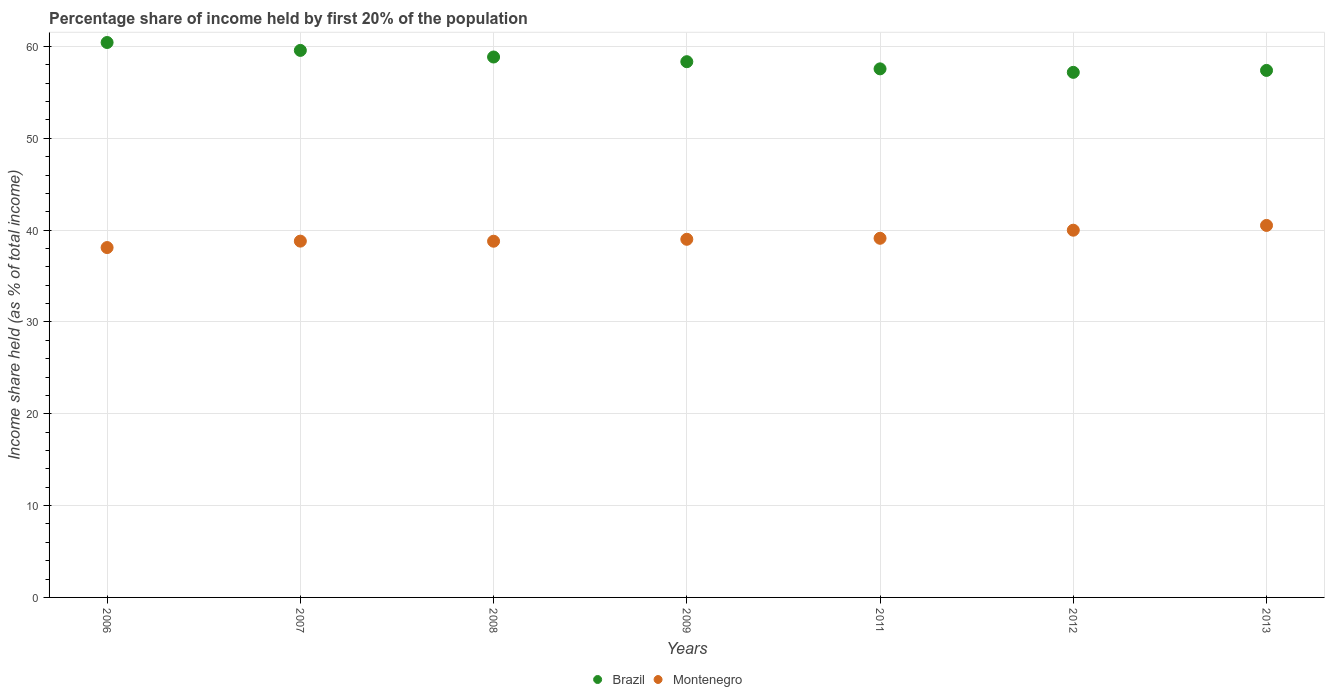How many different coloured dotlines are there?
Make the answer very short. 2. What is the share of income held by first 20% of the population in Montenegro in 2013?
Keep it short and to the point. 40.51. Across all years, what is the maximum share of income held by first 20% of the population in Brazil?
Keep it short and to the point. 60.43. Across all years, what is the minimum share of income held by first 20% of the population in Brazil?
Ensure brevity in your answer.  57.18. In which year was the share of income held by first 20% of the population in Montenegro minimum?
Your response must be concise. 2006. What is the total share of income held by first 20% of the population in Montenegro in the graph?
Offer a very short reply. 274.3. What is the difference between the share of income held by first 20% of the population in Montenegro in 2009 and that in 2011?
Give a very brief answer. -0.11. What is the difference between the share of income held by first 20% of the population in Montenegro in 2006 and the share of income held by first 20% of the population in Brazil in 2009?
Make the answer very short. -20.24. What is the average share of income held by first 20% of the population in Brazil per year?
Offer a terse response. 58.47. In the year 2007, what is the difference between the share of income held by first 20% of the population in Montenegro and share of income held by first 20% of the population in Brazil?
Offer a terse response. -20.77. What is the ratio of the share of income held by first 20% of the population in Montenegro in 2006 to that in 2008?
Your response must be concise. 0.98. Is the share of income held by first 20% of the population in Montenegro in 2009 less than that in 2011?
Your answer should be very brief. Yes. Is the difference between the share of income held by first 20% of the population in Montenegro in 2007 and 2012 greater than the difference between the share of income held by first 20% of the population in Brazil in 2007 and 2012?
Ensure brevity in your answer.  No. What is the difference between the highest and the second highest share of income held by first 20% of the population in Brazil?
Offer a terse response. 0.86. What is the difference between the highest and the lowest share of income held by first 20% of the population in Montenegro?
Ensure brevity in your answer.  2.41. In how many years, is the share of income held by first 20% of the population in Montenegro greater than the average share of income held by first 20% of the population in Montenegro taken over all years?
Ensure brevity in your answer.  2. Is the share of income held by first 20% of the population in Brazil strictly less than the share of income held by first 20% of the population in Montenegro over the years?
Make the answer very short. No. How many years are there in the graph?
Give a very brief answer. 7. What is the difference between two consecutive major ticks on the Y-axis?
Offer a terse response. 10. Are the values on the major ticks of Y-axis written in scientific E-notation?
Make the answer very short. No. Does the graph contain any zero values?
Give a very brief answer. No. Does the graph contain grids?
Make the answer very short. Yes. Where does the legend appear in the graph?
Your answer should be very brief. Bottom center. How are the legend labels stacked?
Offer a terse response. Horizontal. What is the title of the graph?
Your answer should be compact. Percentage share of income held by first 20% of the population. Does "Mali" appear as one of the legend labels in the graph?
Provide a succinct answer. No. What is the label or title of the Y-axis?
Keep it short and to the point. Income share held (as % of total income). What is the Income share held (as % of total income) of Brazil in 2006?
Provide a short and direct response. 60.43. What is the Income share held (as % of total income) of Montenegro in 2006?
Provide a succinct answer. 38.1. What is the Income share held (as % of total income) in Brazil in 2007?
Give a very brief answer. 59.57. What is the Income share held (as % of total income) in Montenegro in 2007?
Your answer should be compact. 38.8. What is the Income share held (as % of total income) of Brazil in 2008?
Keep it short and to the point. 58.85. What is the Income share held (as % of total income) in Montenegro in 2008?
Give a very brief answer. 38.79. What is the Income share held (as % of total income) of Brazil in 2009?
Your answer should be compact. 58.34. What is the Income share held (as % of total income) of Montenegro in 2009?
Provide a succinct answer. 39. What is the Income share held (as % of total income) in Brazil in 2011?
Provide a succinct answer. 57.56. What is the Income share held (as % of total income) in Montenegro in 2011?
Your answer should be compact. 39.11. What is the Income share held (as % of total income) in Brazil in 2012?
Make the answer very short. 57.18. What is the Income share held (as % of total income) of Montenegro in 2012?
Give a very brief answer. 39.99. What is the Income share held (as % of total income) in Brazil in 2013?
Your answer should be very brief. 57.39. What is the Income share held (as % of total income) in Montenegro in 2013?
Your answer should be very brief. 40.51. Across all years, what is the maximum Income share held (as % of total income) of Brazil?
Keep it short and to the point. 60.43. Across all years, what is the maximum Income share held (as % of total income) of Montenegro?
Provide a short and direct response. 40.51. Across all years, what is the minimum Income share held (as % of total income) of Brazil?
Offer a very short reply. 57.18. Across all years, what is the minimum Income share held (as % of total income) of Montenegro?
Keep it short and to the point. 38.1. What is the total Income share held (as % of total income) in Brazil in the graph?
Provide a succinct answer. 409.32. What is the total Income share held (as % of total income) in Montenegro in the graph?
Your answer should be compact. 274.3. What is the difference between the Income share held (as % of total income) of Brazil in 2006 and that in 2007?
Ensure brevity in your answer.  0.86. What is the difference between the Income share held (as % of total income) of Montenegro in 2006 and that in 2007?
Your response must be concise. -0.7. What is the difference between the Income share held (as % of total income) in Brazil in 2006 and that in 2008?
Your answer should be compact. 1.58. What is the difference between the Income share held (as % of total income) in Montenegro in 2006 and that in 2008?
Make the answer very short. -0.69. What is the difference between the Income share held (as % of total income) in Brazil in 2006 and that in 2009?
Your answer should be compact. 2.09. What is the difference between the Income share held (as % of total income) of Montenegro in 2006 and that in 2009?
Make the answer very short. -0.9. What is the difference between the Income share held (as % of total income) of Brazil in 2006 and that in 2011?
Offer a very short reply. 2.87. What is the difference between the Income share held (as % of total income) in Montenegro in 2006 and that in 2011?
Provide a short and direct response. -1.01. What is the difference between the Income share held (as % of total income) in Montenegro in 2006 and that in 2012?
Keep it short and to the point. -1.89. What is the difference between the Income share held (as % of total income) of Brazil in 2006 and that in 2013?
Ensure brevity in your answer.  3.04. What is the difference between the Income share held (as % of total income) of Montenegro in 2006 and that in 2013?
Provide a succinct answer. -2.41. What is the difference between the Income share held (as % of total income) of Brazil in 2007 and that in 2008?
Provide a succinct answer. 0.72. What is the difference between the Income share held (as % of total income) of Montenegro in 2007 and that in 2008?
Your answer should be very brief. 0.01. What is the difference between the Income share held (as % of total income) of Brazil in 2007 and that in 2009?
Provide a short and direct response. 1.23. What is the difference between the Income share held (as % of total income) in Brazil in 2007 and that in 2011?
Keep it short and to the point. 2.01. What is the difference between the Income share held (as % of total income) in Montenegro in 2007 and that in 2011?
Ensure brevity in your answer.  -0.31. What is the difference between the Income share held (as % of total income) of Brazil in 2007 and that in 2012?
Give a very brief answer. 2.39. What is the difference between the Income share held (as % of total income) in Montenegro in 2007 and that in 2012?
Your answer should be compact. -1.19. What is the difference between the Income share held (as % of total income) in Brazil in 2007 and that in 2013?
Your answer should be compact. 2.18. What is the difference between the Income share held (as % of total income) in Montenegro in 2007 and that in 2013?
Your answer should be compact. -1.71. What is the difference between the Income share held (as % of total income) of Brazil in 2008 and that in 2009?
Provide a short and direct response. 0.51. What is the difference between the Income share held (as % of total income) in Montenegro in 2008 and that in 2009?
Ensure brevity in your answer.  -0.21. What is the difference between the Income share held (as % of total income) in Brazil in 2008 and that in 2011?
Make the answer very short. 1.29. What is the difference between the Income share held (as % of total income) in Montenegro in 2008 and that in 2011?
Your response must be concise. -0.32. What is the difference between the Income share held (as % of total income) in Brazil in 2008 and that in 2012?
Your answer should be compact. 1.67. What is the difference between the Income share held (as % of total income) of Montenegro in 2008 and that in 2012?
Your answer should be very brief. -1.2. What is the difference between the Income share held (as % of total income) in Brazil in 2008 and that in 2013?
Your response must be concise. 1.46. What is the difference between the Income share held (as % of total income) of Montenegro in 2008 and that in 2013?
Give a very brief answer. -1.72. What is the difference between the Income share held (as % of total income) of Brazil in 2009 and that in 2011?
Ensure brevity in your answer.  0.78. What is the difference between the Income share held (as % of total income) in Montenegro in 2009 and that in 2011?
Give a very brief answer. -0.11. What is the difference between the Income share held (as % of total income) in Brazil in 2009 and that in 2012?
Keep it short and to the point. 1.16. What is the difference between the Income share held (as % of total income) of Montenegro in 2009 and that in 2012?
Your response must be concise. -0.99. What is the difference between the Income share held (as % of total income) of Brazil in 2009 and that in 2013?
Your response must be concise. 0.95. What is the difference between the Income share held (as % of total income) in Montenegro in 2009 and that in 2013?
Keep it short and to the point. -1.51. What is the difference between the Income share held (as % of total income) of Brazil in 2011 and that in 2012?
Your answer should be very brief. 0.38. What is the difference between the Income share held (as % of total income) of Montenegro in 2011 and that in 2012?
Your answer should be very brief. -0.88. What is the difference between the Income share held (as % of total income) of Brazil in 2011 and that in 2013?
Give a very brief answer. 0.17. What is the difference between the Income share held (as % of total income) of Brazil in 2012 and that in 2013?
Ensure brevity in your answer.  -0.21. What is the difference between the Income share held (as % of total income) of Montenegro in 2012 and that in 2013?
Your answer should be very brief. -0.52. What is the difference between the Income share held (as % of total income) in Brazil in 2006 and the Income share held (as % of total income) in Montenegro in 2007?
Your answer should be compact. 21.63. What is the difference between the Income share held (as % of total income) in Brazil in 2006 and the Income share held (as % of total income) in Montenegro in 2008?
Offer a terse response. 21.64. What is the difference between the Income share held (as % of total income) in Brazil in 2006 and the Income share held (as % of total income) in Montenegro in 2009?
Keep it short and to the point. 21.43. What is the difference between the Income share held (as % of total income) of Brazil in 2006 and the Income share held (as % of total income) of Montenegro in 2011?
Offer a very short reply. 21.32. What is the difference between the Income share held (as % of total income) in Brazil in 2006 and the Income share held (as % of total income) in Montenegro in 2012?
Your answer should be very brief. 20.44. What is the difference between the Income share held (as % of total income) in Brazil in 2006 and the Income share held (as % of total income) in Montenegro in 2013?
Offer a terse response. 19.92. What is the difference between the Income share held (as % of total income) in Brazil in 2007 and the Income share held (as % of total income) in Montenegro in 2008?
Your answer should be compact. 20.78. What is the difference between the Income share held (as % of total income) of Brazil in 2007 and the Income share held (as % of total income) of Montenegro in 2009?
Give a very brief answer. 20.57. What is the difference between the Income share held (as % of total income) in Brazil in 2007 and the Income share held (as % of total income) in Montenegro in 2011?
Ensure brevity in your answer.  20.46. What is the difference between the Income share held (as % of total income) of Brazil in 2007 and the Income share held (as % of total income) of Montenegro in 2012?
Your answer should be compact. 19.58. What is the difference between the Income share held (as % of total income) in Brazil in 2007 and the Income share held (as % of total income) in Montenegro in 2013?
Your response must be concise. 19.06. What is the difference between the Income share held (as % of total income) of Brazil in 2008 and the Income share held (as % of total income) of Montenegro in 2009?
Ensure brevity in your answer.  19.85. What is the difference between the Income share held (as % of total income) of Brazil in 2008 and the Income share held (as % of total income) of Montenegro in 2011?
Give a very brief answer. 19.74. What is the difference between the Income share held (as % of total income) of Brazil in 2008 and the Income share held (as % of total income) of Montenegro in 2012?
Offer a terse response. 18.86. What is the difference between the Income share held (as % of total income) in Brazil in 2008 and the Income share held (as % of total income) in Montenegro in 2013?
Offer a terse response. 18.34. What is the difference between the Income share held (as % of total income) in Brazil in 2009 and the Income share held (as % of total income) in Montenegro in 2011?
Give a very brief answer. 19.23. What is the difference between the Income share held (as % of total income) of Brazil in 2009 and the Income share held (as % of total income) of Montenegro in 2012?
Offer a terse response. 18.35. What is the difference between the Income share held (as % of total income) in Brazil in 2009 and the Income share held (as % of total income) in Montenegro in 2013?
Offer a terse response. 17.83. What is the difference between the Income share held (as % of total income) in Brazil in 2011 and the Income share held (as % of total income) in Montenegro in 2012?
Provide a succinct answer. 17.57. What is the difference between the Income share held (as % of total income) in Brazil in 2011 and the Income share held (as % of total income) in Montenegro in 2013?
Give a very brief answer. 17.05. What is the difference between the Income share held (as % of total income) of Brazil in 2012 and the Income share held (as % of total income) of Montenegro in 2013?
Ensure brevity in your answer.  16.67. What is the average Income share held (as % of total income) in Brazil per year?
Your answer should be compact. 58.47. What is the average Income share held (as % of total income) in Montenegro per year?
Give a very brief answer. 39.19. In the year 2006, what is the difference between the Income share held (as % of total income) of Brazil and Income share held (as % of total income) of Montenegro?
Your answer should be compact. 22.33. In the year 2007, what is the difference between the Income share held (as % of total income) in Brazil and Income share held (as % of total income) in Montenegro?
Offer a terse response. 20.77. In the year 2008, what is the difference between the Income share held (as % of total income) in Brazil and Income share held (as % of total income) in Montenegro?
Offer a terse response. 20.06. In the year 2009, what is the difference between the Income share held (as % of total income) in Brazil and Income share held (as % of total income) in Montenegro?
Provide a short and direct response. 19.34. In the year 2011, what is the difference between the Income share held (as % of total income) in Brazil and Income share held (as % of total income) in Montenegro?
Provide a short and direct response. 18.45. In the year 2012, what is the difference between the Income share held (as % of total income) of Brazil and Income share held (as % of total income) of Montenegro?
Provide a succinct answer. 17.19. In the year 2013, what is the difference between the Income share held (as % of total income) in Brazil and Income share held (as % of total income) in Montenegro?
Keep it short and to the point. 16.88. What is the ratio of the Income share held (as % of total income) of Brazil in 2006 to that in 2007?
Your answer should be very brief. 1.01. What is the ratio of the Income share held (as % of total income) of Montenegro in 2006 to that in 2007?
Ensure brevity in your answer.  0.98. What is the ratio of the Income share held (as % of total income) in Brazil in 2006 to that in 2008?
Your answer should be compact. 1.03. What is the ratio of the Income share held (as % of total income) of Montenegro in 2006 to that in 2008?
Provide a succinct answer. 0.98. What is the ratio of the Income share held (as % of total income) of Brazil in 2006 to that in 2009?
Offer a very short reply. 1.04. What is the ratio of the Income share held (as % of total income) of Montenegro in 2006 to that in 2009?
Provide a succinct answer. 0.98. What is the ratio of the Income share held (as % of total income) in Brazil in 2006 to that in 2011?
Your response must be concise. 1.05. What is the ratio of the Income share held (as % of total income) of Montenegro in 2006 to that in 2011?
Provide a succinct answer. 0.97. What is the ratio of the Income share held (as % of total income) in Brazil in 2006 to that in 2012?
Offer a terse response. 1.06. What is the ratio of the Income share held (as % of total income) of Montenegro in 2006 to that in 2012?
Give a very brief answer. 0.95. What is the ratio of the Income share held (as % of total income) of Brazil in 2006 to that in 2013?
Ensure brevity in your answer.  1.05. What is the ratio of the Income share held (as % of total income) of Montenegro in 2006 to that in 2013?
Offer a very short reply. 0.94. What is the ratio of the Income share held (as % of total income) of Brazil in 2007 to that in 2008?
Your answer should be very brief. 1.01. What is the ratio of the Income share held (as % of total income) in Brazil in 2007 to that in 2009?
Offer a terse response. 1.02. What is the ratio of the Income share held (as % of total income) of Brazil in 2007 to that in 2011?
Provide a succinct answer. 1.03. What is the ratio of the Income share held (as % of total income) in Brazil in 2007 to that in 2012?
Provide a succinct answer. 1.04. What is the ratio of the Income share held (as % of total income) in Montenegro in 2007 to that in 2012?
Offer a terse response. 0.97. What is the ratio of the Income share held (as % of total income) of Brazil in 2007 to that in 2013?
Offer a very short reply. 1.04. What is the ratio of the Income share held (as % of total income) in Montenegro in 2007 to that in 2013?
Give a very brief answer. 0.96. What is the ratio of the Income share held (as % of total income) in Brazil in 2008 to that in 2009?
Keep it short and to the point. 1.01. What is the ratio of the Income share held (as % of total income) in Brazil in 2008 to that in 2011?
Keep it short and to the point. 1.02. What is the ratio of the Income share held (as % of total income) in Montenegro in 2008 to that in 2011?
Offer a terse response. 0.99. What is the ratio of the Income share held (as % of total income) in Brazil in 2008 to that in 2012?
Give a very brief answer. 1.03. What is the ratio of the Income share held (as % of total income) in Brazil in 2008 to that in 2013?
Make the answer very short. 1.03. What is the ratio of the Income share held (as % of total income) in Montenegro in 2008 to that in 2013?
Your answer should be compact. 0.96. What is the ratio of the Income share held (as % of total income) in Brazil in 2009 to that in 2011?
Your answer should be very brief. 1.01. What is the ratio of the Income share held (as % of total income) in Montenegro in 2009 to that in 2011?
Keep it short and to the point. 1. What is the ratio of the Income share held (as % of total income) in Brazil in 2009 to that in 2012?
Your response must be concise. 1.02. What is the ratio of the Income share held (as % of total income) of Montenegro in 2009 to that in 2012?
Provide a succinct answer. 0.98. What is the ratio of the Income share held (as % of total income) in Brazil in 2009 to that in 2013?
Provide a succinct answer. 1.02. What is the ratio of the Income share held (as % of total income) of Montenegro in 2009 to that in 2013?
Give a very brief answer. 0.96. What is the ratio of the Income share held (as % of total income) of Brazil in 2011 to that in 2012?
Give a very brief answer. 1.01. What is the ratio of the Income share held (as % of total income) of Montenegro in 2011 to that in 2012?
Make the answer very short. 0.98. What is the ratio of the Income share held (as % of total income) of Brazil in 2011 to that in 2013?
Ensure brevity in your answer.  1. What is the ratio of the Income share held (as % of total income) in Montenegro in 2011 to that in 2013?
Make the answer very short. 0.97. What is the ratio of the Income share held (as % of total income) in Montenegro in 2012 to that in 2013?
Keep it short and to the point. 0.99. What is the difference between the highest and the second highest Income share held (as % of total income) of Brazil?
Keep it short and to the point. 0.86. What is the difference between the highest and the second highest Income share held (as % of total income) in Montenegro?
Your response must be concise. 0.52. What is the difference between the highest and the lowest Income share held (as % of total income) in Montenegro?
Your response must be concise. 2.41. 